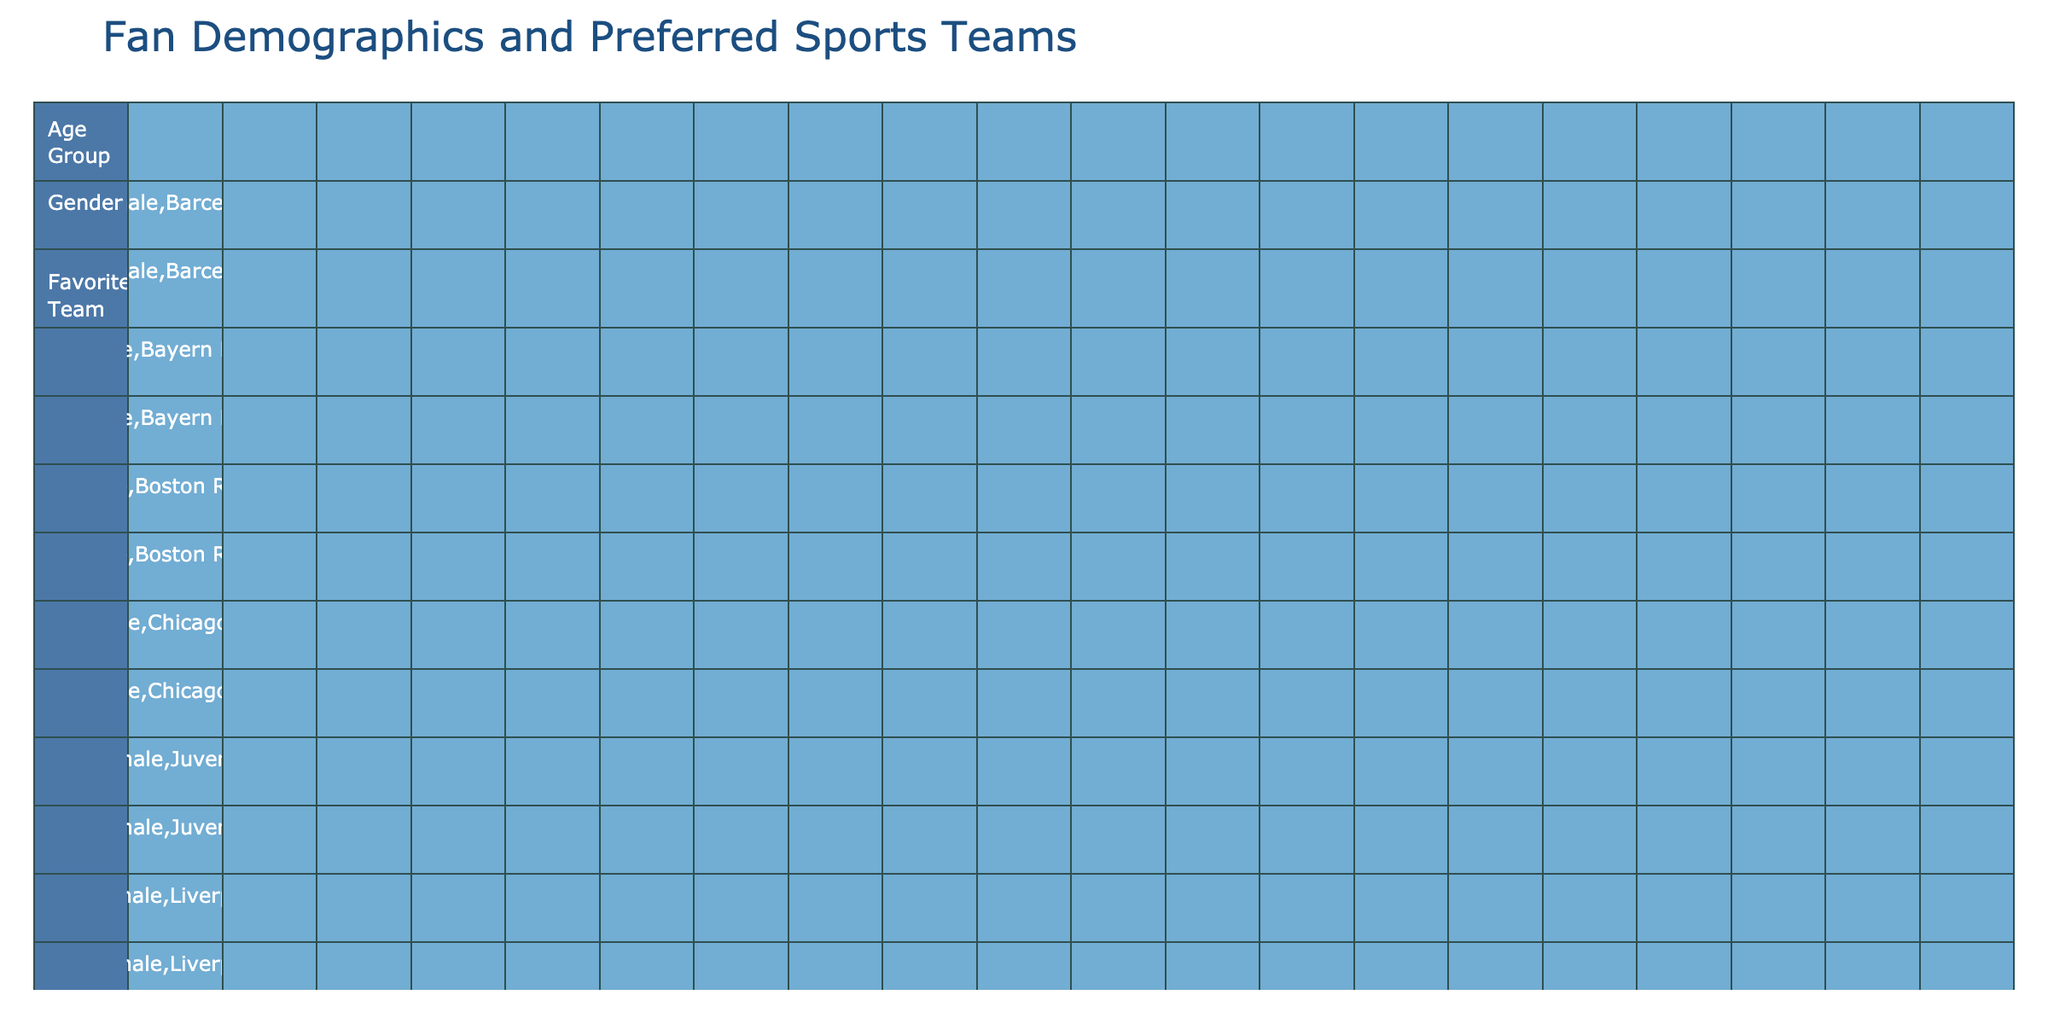What is the favorite team of the 18-24 female fans? There is only one entry for this demographic mentioned with a favorite team, which is the Boston Red Sox.
Answer: Boston Red Sox How many male fans support the Green Bay Packers? Referring to the table, only one entry lists the Green Bay Packers as a favorite team for the male fans in the 55+ age group.
Answer: 1 What is the most popular team among fans aged 25-34? We count the distinct favorite teams listed for the 25-34 age group: New England Patriots, Chicago Bulls, Chelsea FC, and Barcelona. Since there is no explicit combination of favorite support beyond each individual team, we note that there are four different teams but no clear "most popular".
Answer: 4 different teams Do any females over the age of 55 support the Los Angeles Sparks? We check the entries for females in the 55+ category and find one entry that lists Los Angeles Sparks, confirming the support.
Answer: Yes Which age group has the most diverse teams listed? We will count the number of distinct teams supported by each age group: (18-24) - 4 teams, (25-34) - 4 teams, (35-44) - 4 teams, (45-54) - 4 teams, (55+) - 3 teams. All age groups except 55+ have equal diversity of four teams.
Answer: 18-24, 25-34, 35-44, 45-54 What percentage of 35-44 year old male fans prefer the Golden State Warriors? Assessing the entries for age group 35-44 male fans shows just one entry for Golden State Warriors out of a total of 4 different teams so the percentage is (1/4) * 100 = 25%.
Answer: 25% Is there a female fan aged 45-54 that supports Bayern Munich? Looking into the entries for females aged 45-54, we identify that Bayern Munich appears as a favorite team, confirming the presence of such fans.
Answer: Yes How many total fans are there in the 55+ age group? Counting the entries in the 55+ age group shows five fans: 3 males and 2 females.
Answer: 5 